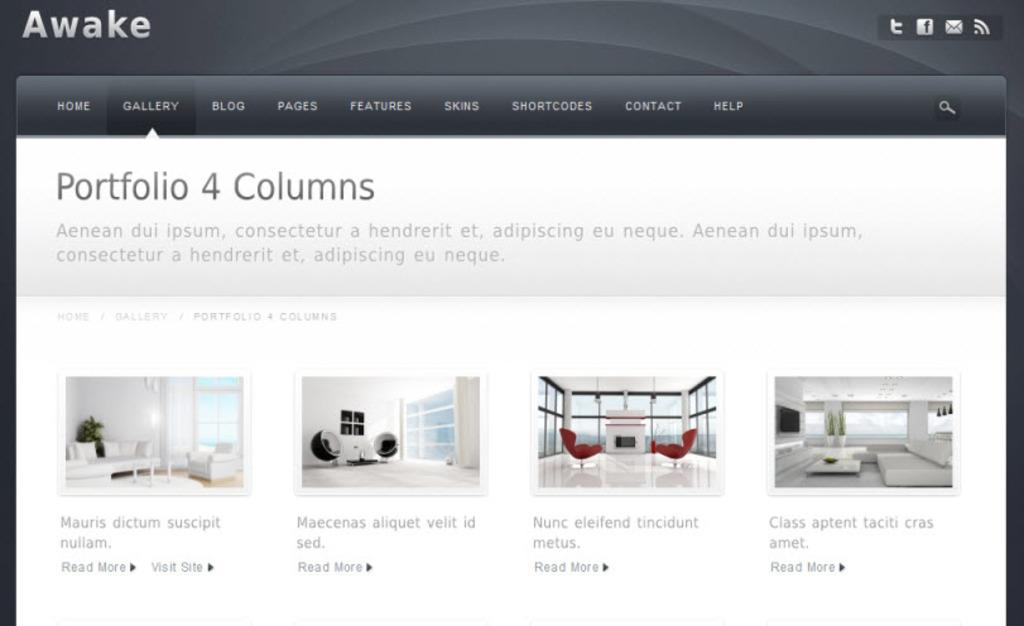What is the main object in the image? There is a screen in the image. What can be seen on the screen? There is text or something written on the screen. What type of furniture is present in the image? There are white and red couches in the image. What architectural feature is visible in the image? There are windows in the image. What type of muscle is visible in the image? There is no muscle visible in the image; it features a screen, text, couches, and windows. 